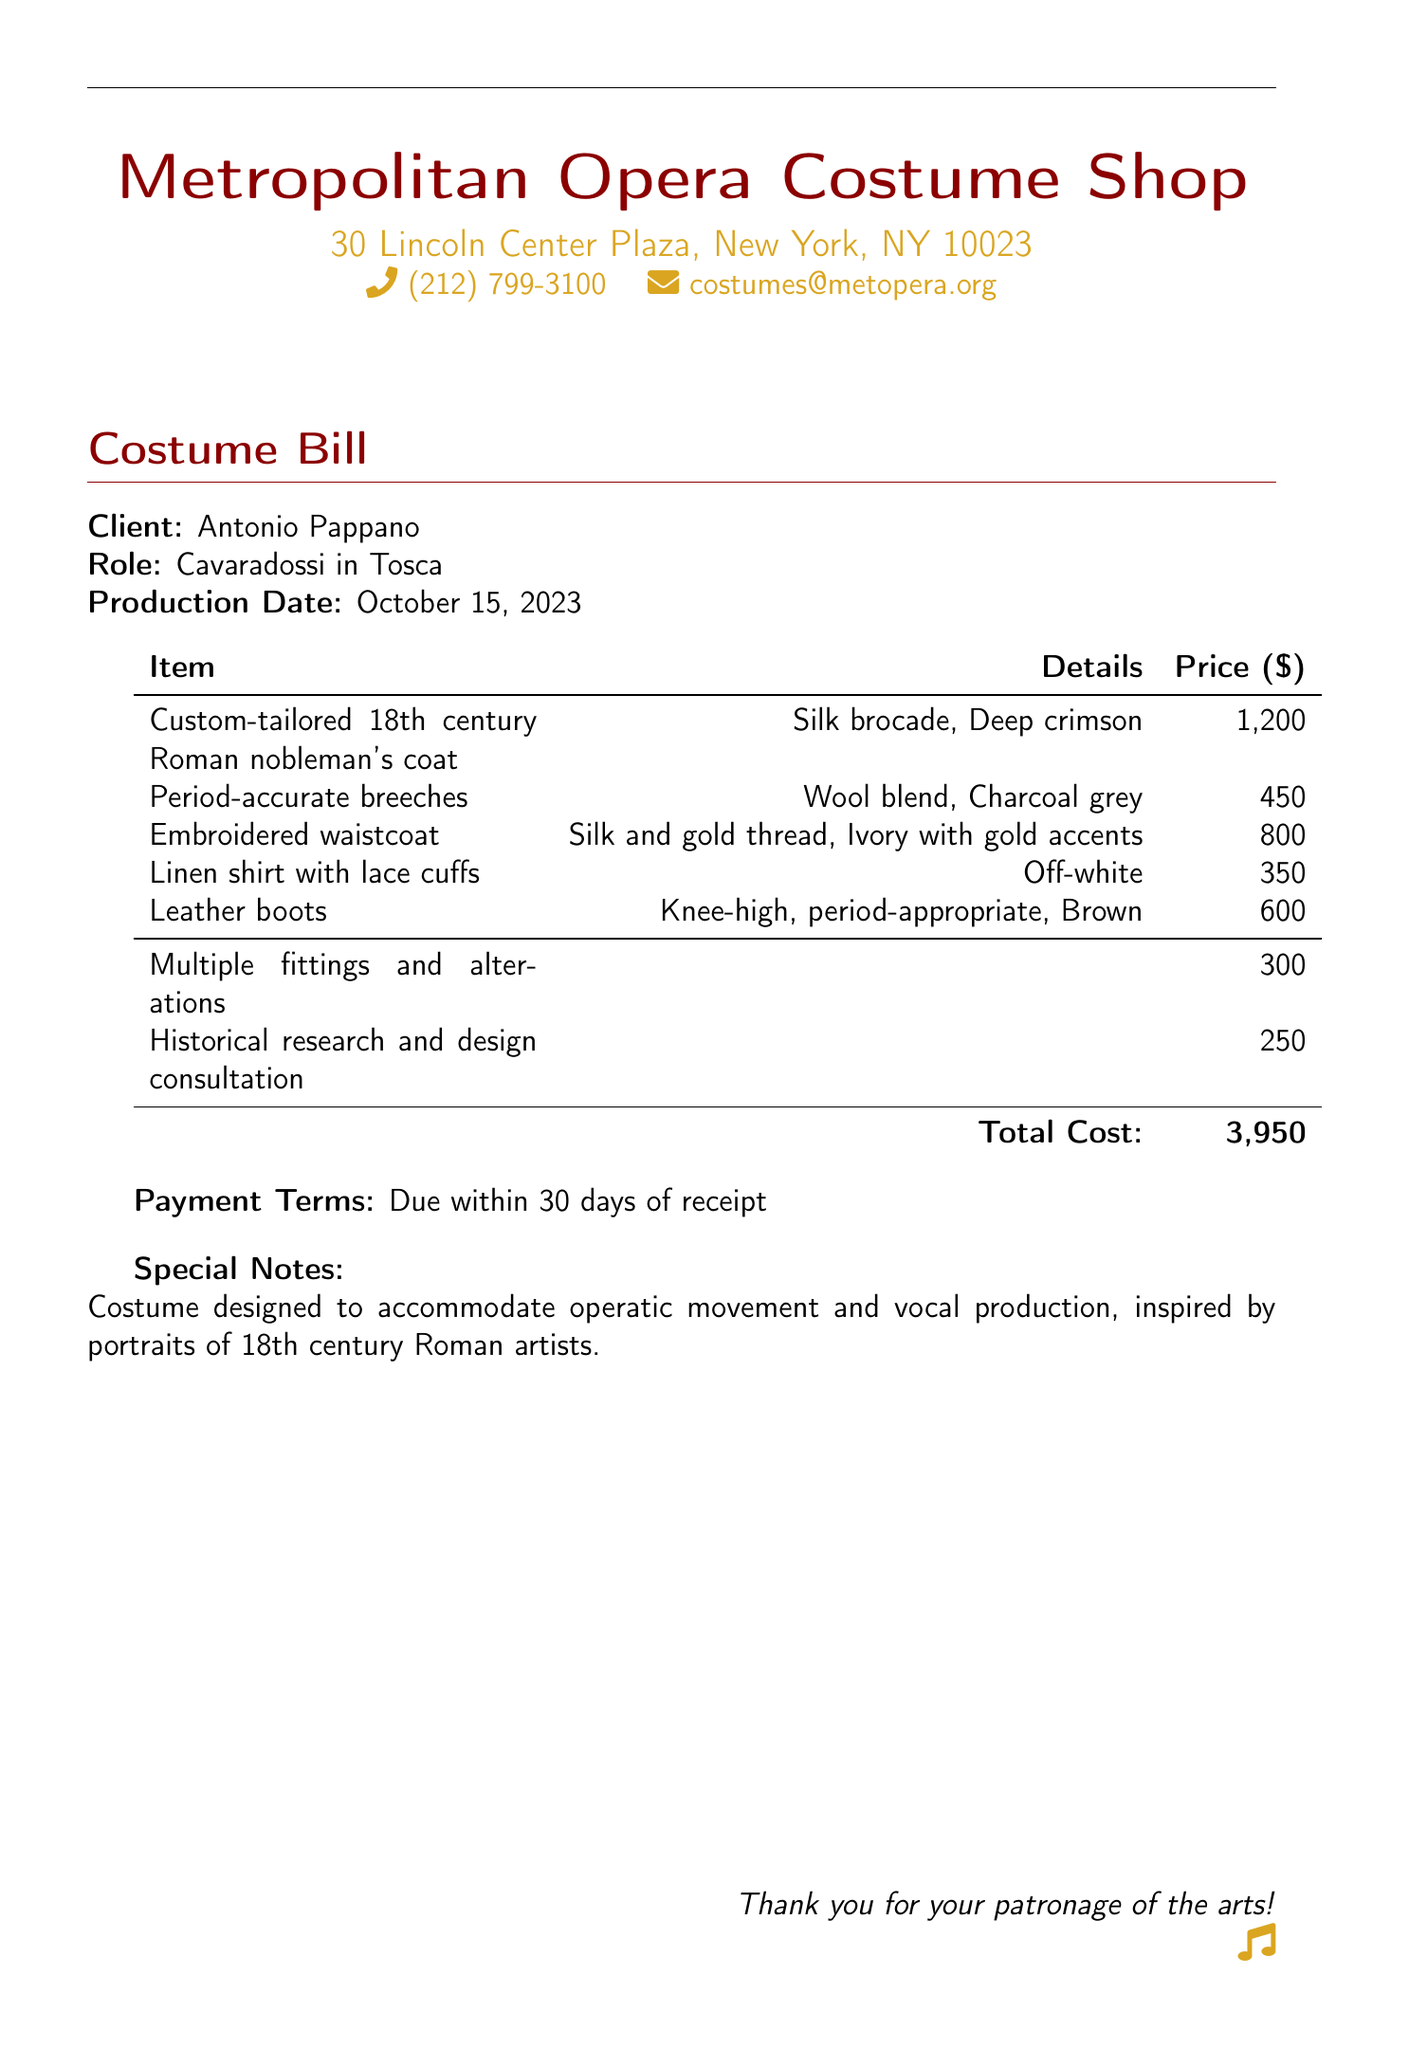What is the client's name? The client's name is clearly mentioned at the top of the bill under the "Client" section.
Answer: Antonio Pappano What is the role of the client? The document states the role of the client in the production, which is indicated under the "Role" section.
Answer: Cavaradossi in Tosca What is the total cost of the costume? The total cost is summarized at the bottom of the bill, next to "Total Cost."
Answer: 3,950 What is the due date for payment? The payment terms indicate that the payment is due within 30 days of receipt.
Answer: Within 30 days How much was charged for historical research and design consultation? The billing section provides the cost associated with historical research and design consultation.
Answer: 250 What type of fabric is used for the coat? The coat description in the bill specifies the type of fabric used for the custom-tailored coat.
Answer: Silk brocade How many fittings and alterations were charged? The bill includes a line item for fittings and alterations, which shows the charge.
Answer: 300 What is the color of the breeches? The color of the breeches is explicitly mentioned in the details of the itemized list.
Answer: Charcoal grey What is noted about the costume's design? The final notes section provides special insights about the costume's design and its considerations.
Answer: Designed to accommodate operatic movement and vocal production 